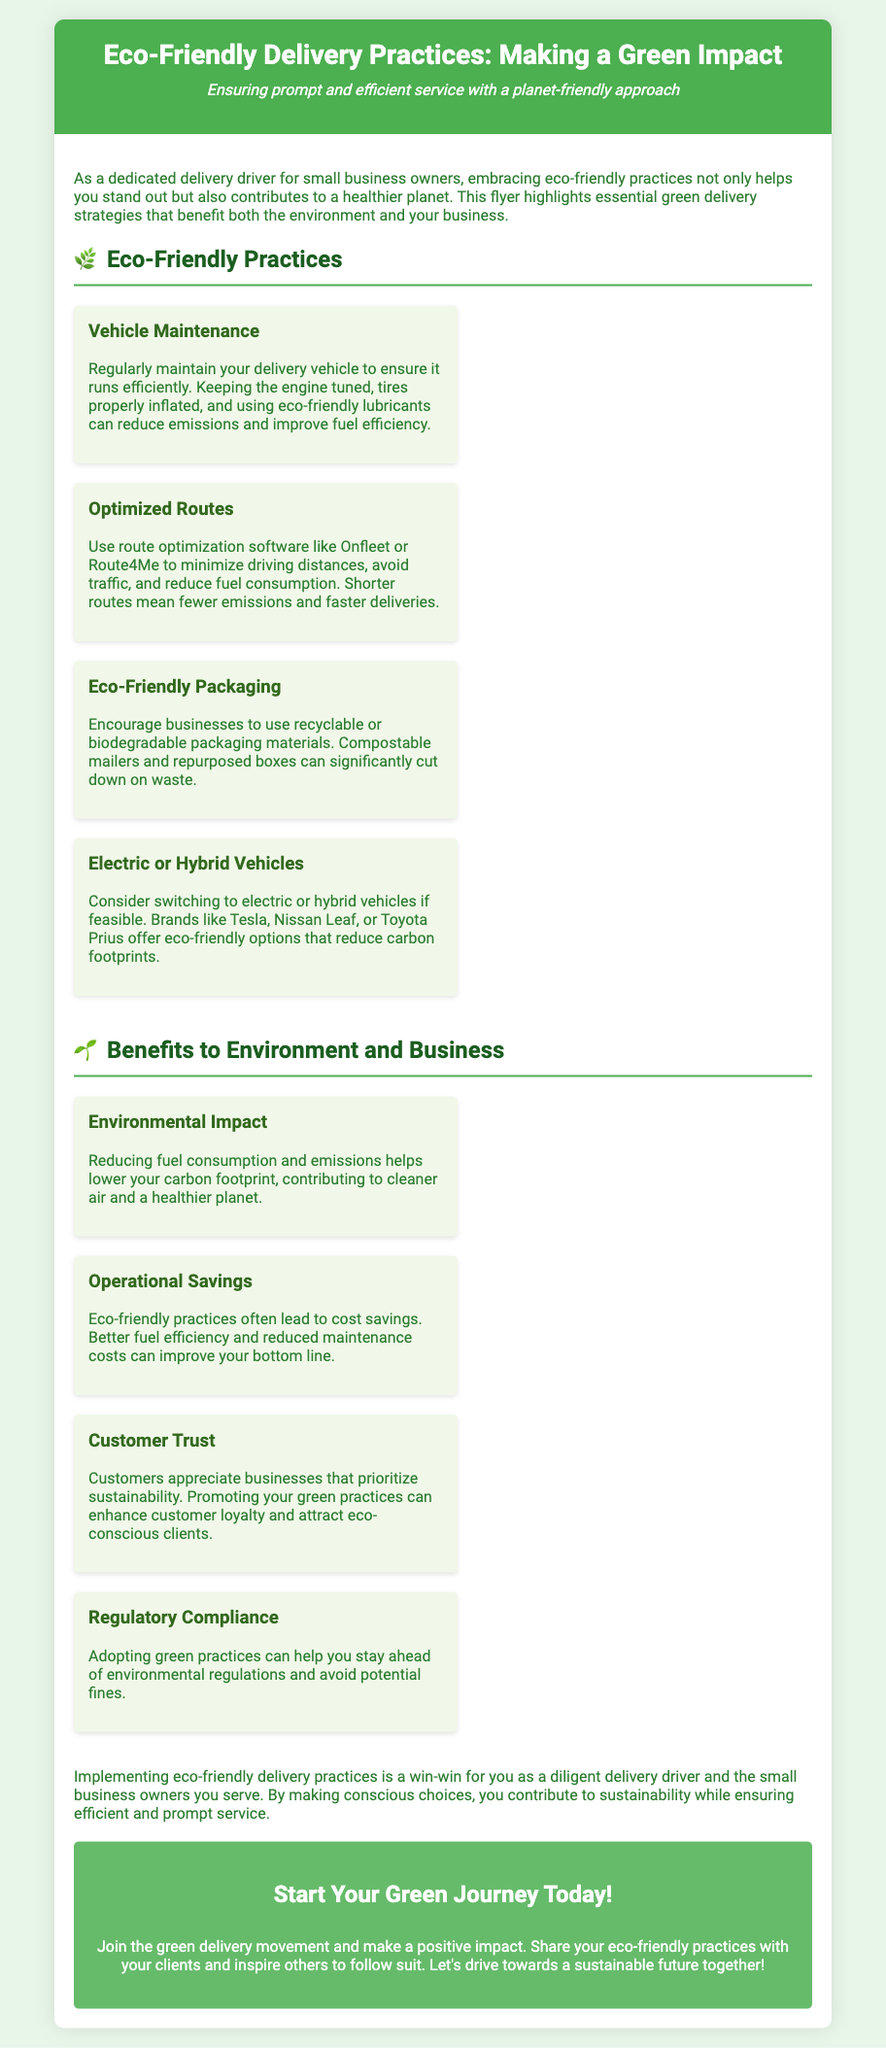what is the title of the flyer? The title of the flyer is prominently displayed at the top of the document.
Answer: Eco-Friendly Delivery Practices: Making a Green Impact how many eco-friendly practices are listed? The document contains a section that lists the eco-friendly practices, which includes four items.
Answer: Four what is one example of an eco-friendly vehicle option? The document provides examples of eco-friendly vehicles in one of the sections.
Answer: Tesla what are the benefits of eco-friendly practices? The document includes a section detailing the numerous benefits of these practices, which specifies four benefits.
Answer: Environmental Impact, Operational Savings, Customer Trust, Regulatory Compliance which practice focuses on route efficiency? The listed practices include a specific item related to routing and distance.
Answer: Optimized Routes what icon represents eco-friendly practices? Each section has icons to visually represent the themes, including one for eco-friendly practices.
Answer: 🌿 how can eco-friendly practices impact customer relations? The document explains how these practices can enhance customer loyalty and attract clients.
Answer: Customer Trust what is the call to action in the flyer? At the end of the document, there is a motivational statement encouraging engagement.
Answer: Start Your Green Journey Today! 